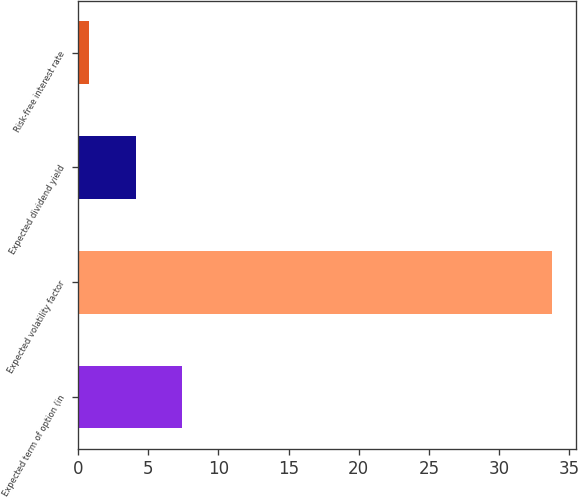Convert chart. <chart><loc_0><loc_0><loc_500><loc_500><bar_chart><fcel>Expected term of option (in<fcel>Expected volatility factor<fcel>Expected dividend yield<fcel>Risk-free interest rate<nl><fcel>7.39<fcel>33.79<fcel>4.09<fcel>0.79<nl></chart> 